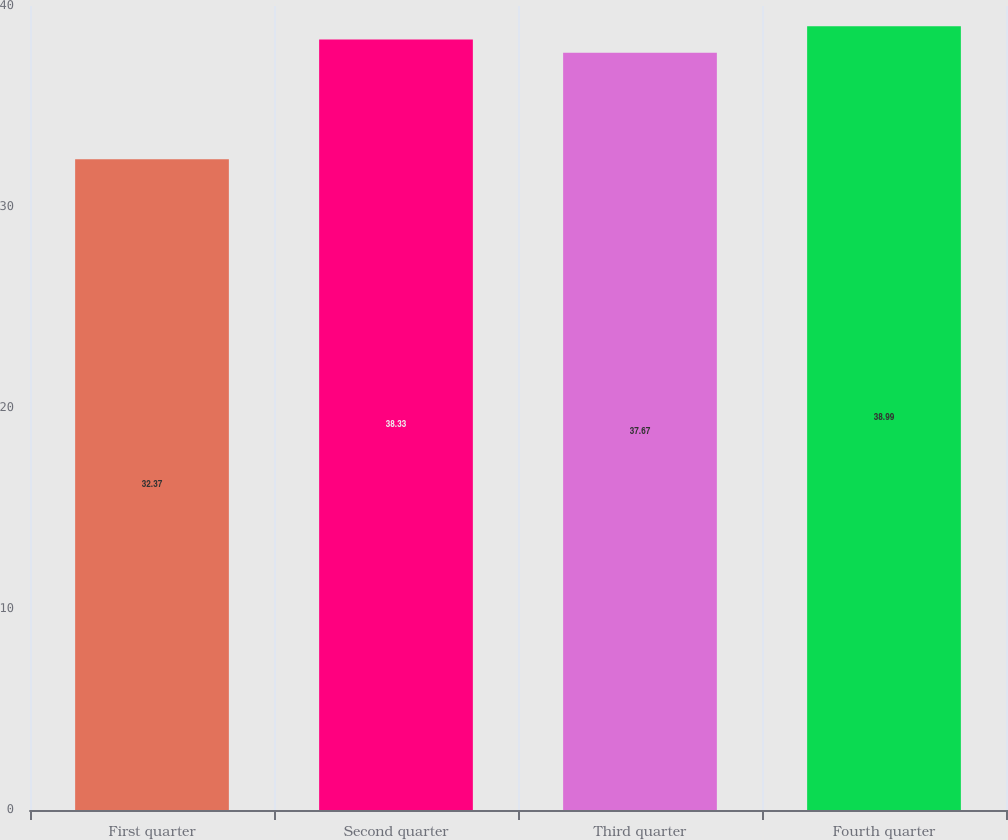<chart> <loc_0><loc_0><loc_500><loc_500><bar_chart><fcel>First quarter<fcel>Second quarter<fcel>Third quarter<fcel>Fourth quarter<nl><fcel>32.37<fcel>38.33<fcel>37.67<fcel>38.99<nl></chart> 